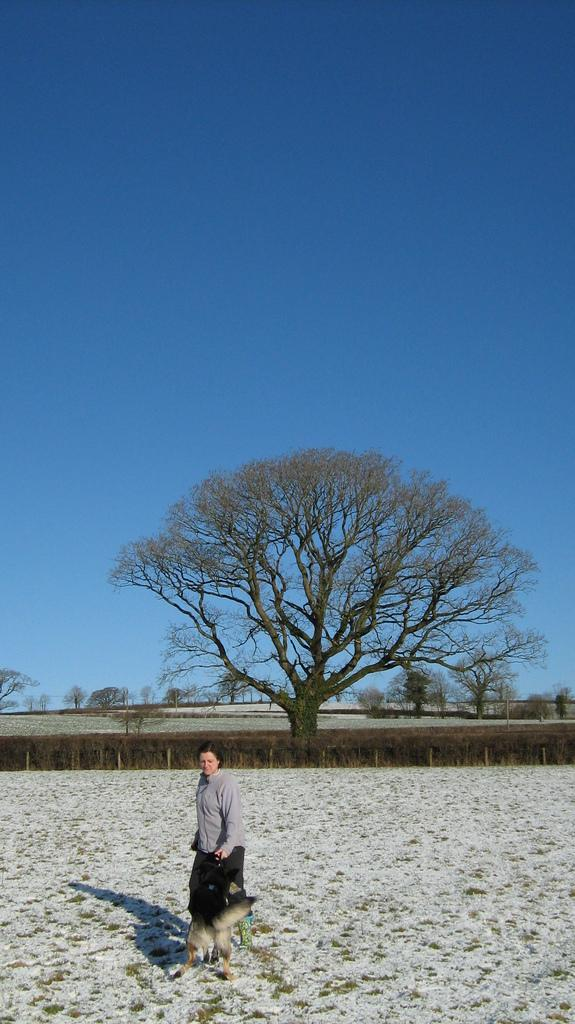Who is the main subject in the front of the image? There is a woman in the front of the image. What type of terrain is visible in the front of the image? There is sand in the front of the image. What other living creature is present in the front of the image? There is a dog in the front of the image. What type of vegetation can be seen in the background of the image? There are plants and trees in the background of the image. What part of the natural environment is visible in the background of the image? The sky is visible in the background of the image. What type of knee injury does the woman have in the image? There is no indication of a knee injury in the image; the woman appears to be standing and walking without any visible issues. What type of quiver is the dog carrying in the image? There is no quiver present in the image; the dog is simply standing or walking alongside the woman. 